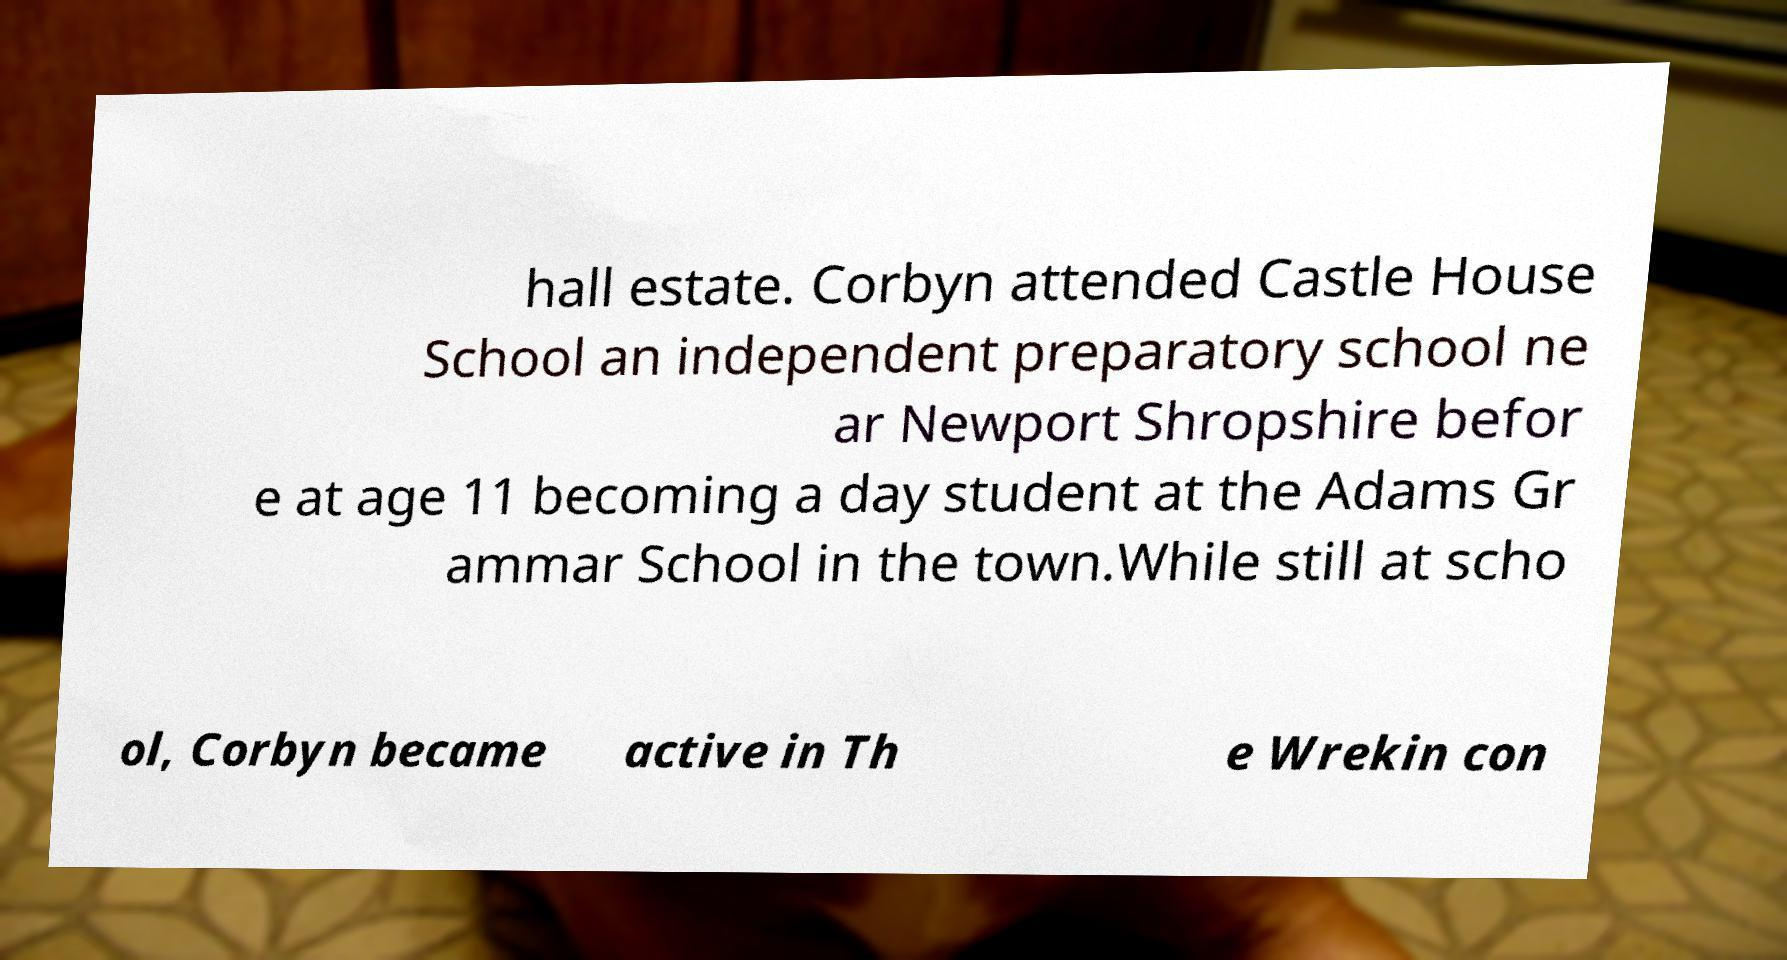There's text embedded in this image that I need extracted. Can you transcribe it verbatim? hall estate. Corbyn attended Castle House School an independent preparatory school ne ar Newport Shropshire befor e at age 11 becoming a day student at the Adams Gr ammar School in the town.While still at scho ol, Corbyn became active in Th e Wrekin con 